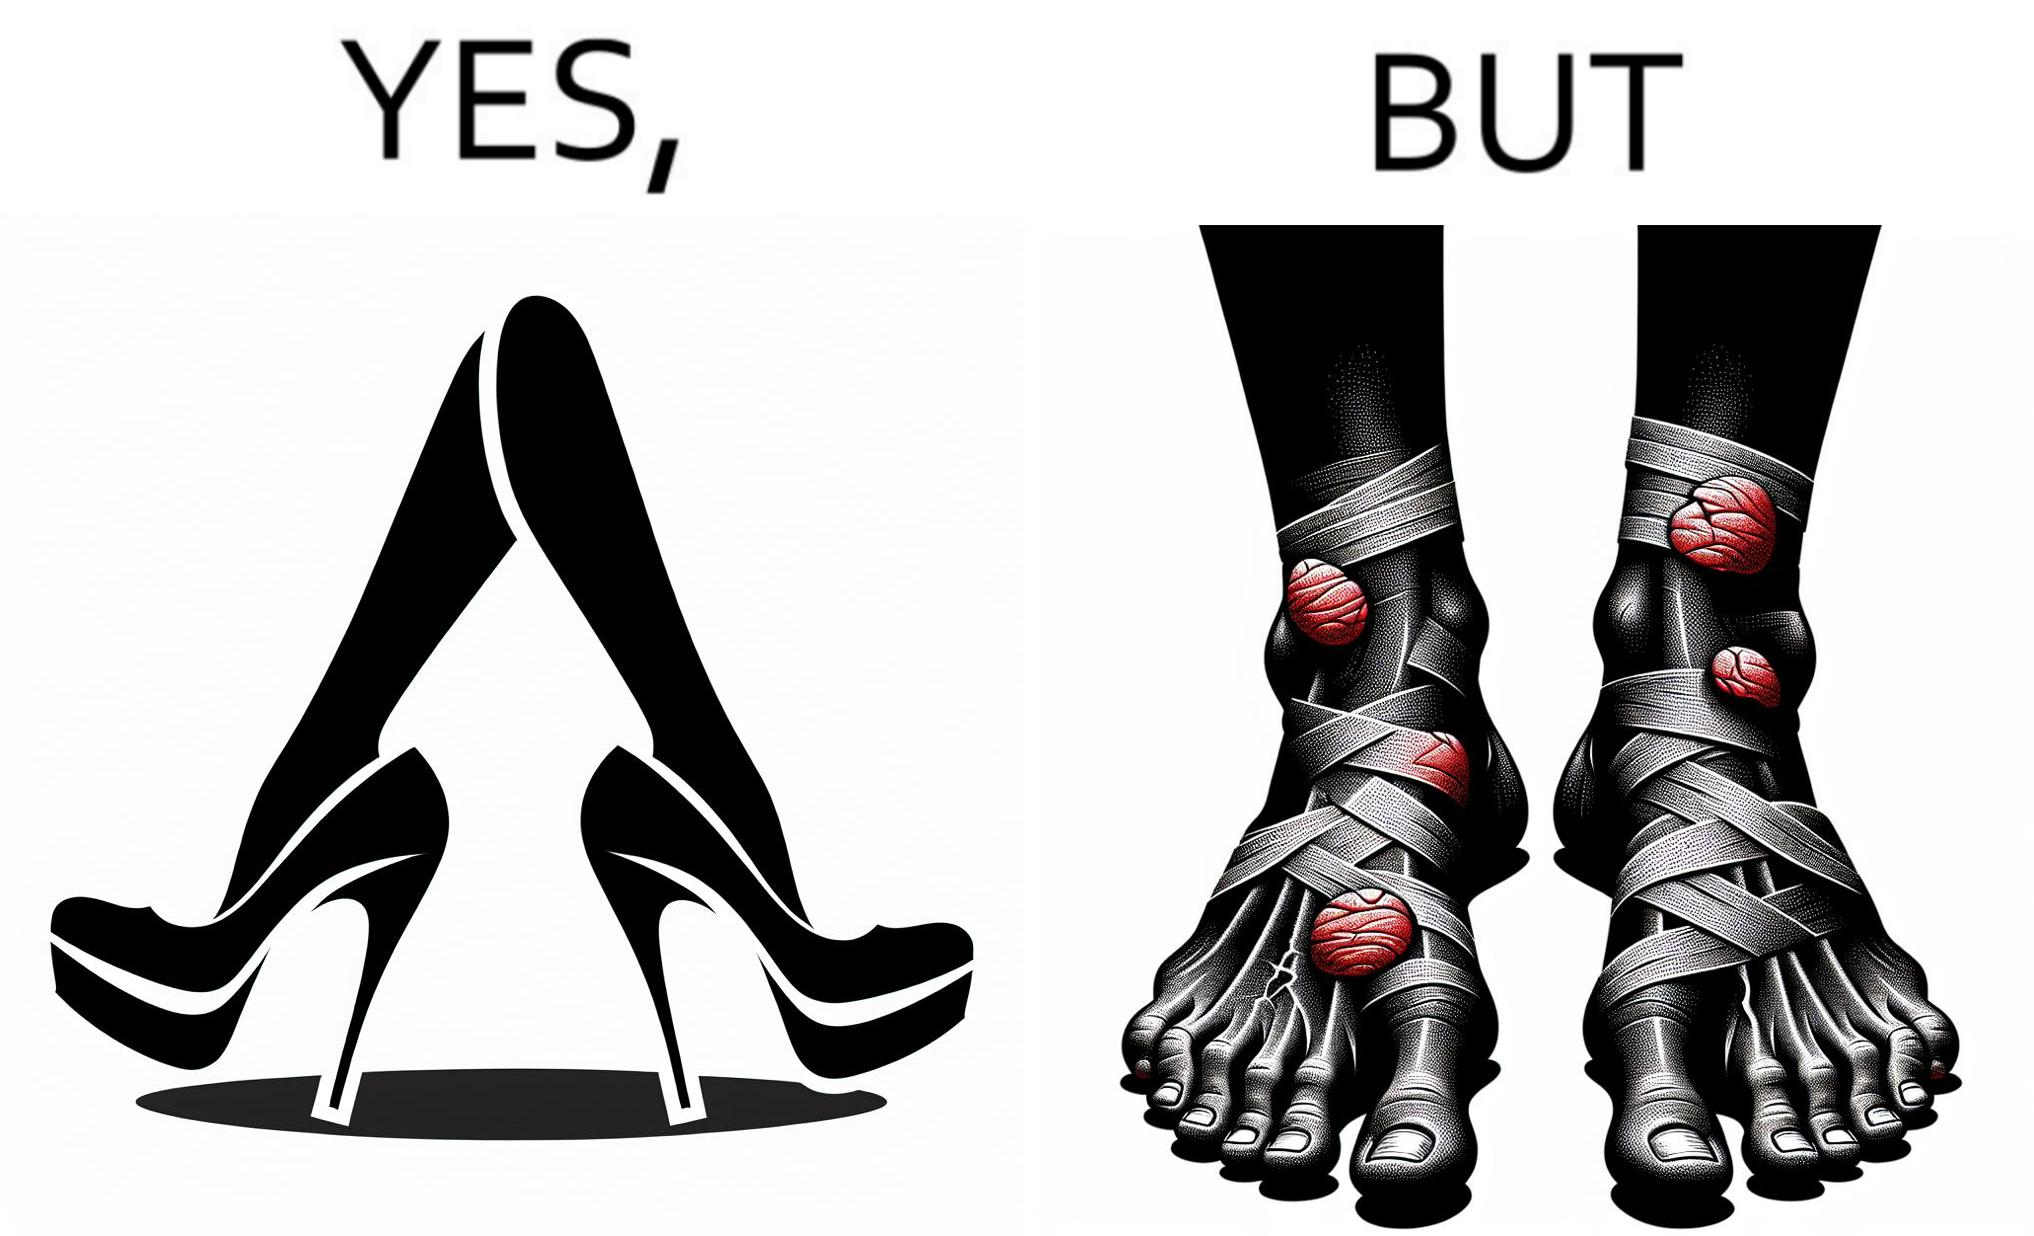Describe the contrast between the left and right parts of this image. In the left part of the image: a pair of high heeled shoes In the right part of the image: A pair of feet, blistered and red, with bandages 